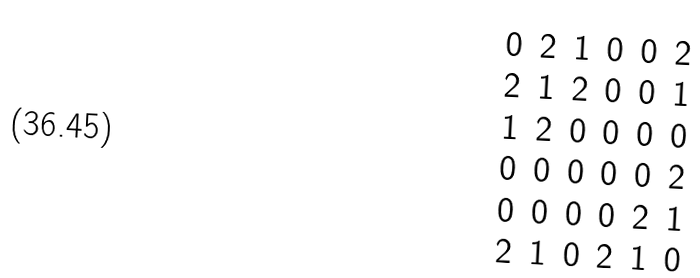Convert formula to latex. <formula><loc_0><loc_0><loc_500><loc_500>\begin{matrix} 0 & 2 & 1 & 0 & 0 & 2 \\ 2 & 1 & 2 & 0 & 0 & 1 \\ 1 & 2 & 0 & 0 & 0 & 0 \\ 0 & 0 & 0 & 0 & 0 & 2 \\ 0 & 0 & 0 & 0 & 2 & 1 \\ 2 & 1 & 0 & 2 & 1 & 0 \end{matrix}</formula> 